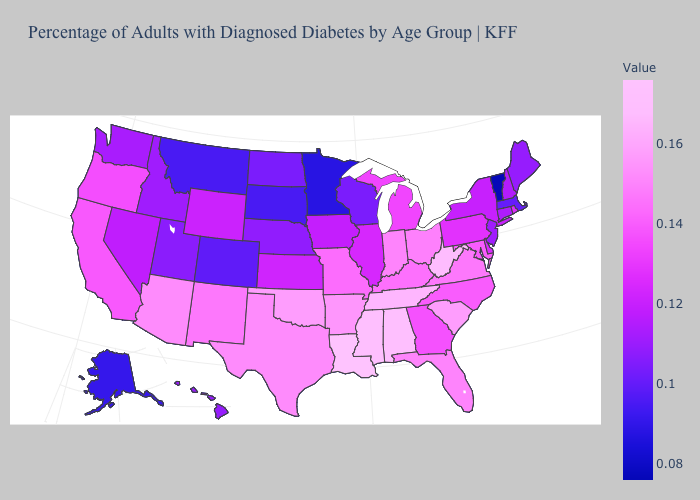Which states have the lowest value in the USA?
Short answer required. Vermont. Among the states that border Washington , which have the highest value?
Concise answer only. Oregon. Does South Dakota have the highest value in the MidWest?
Answer briefly. No. Among the states that border Nevada , does Arizona have the highest value?
Give a very brief answer. Yes. 